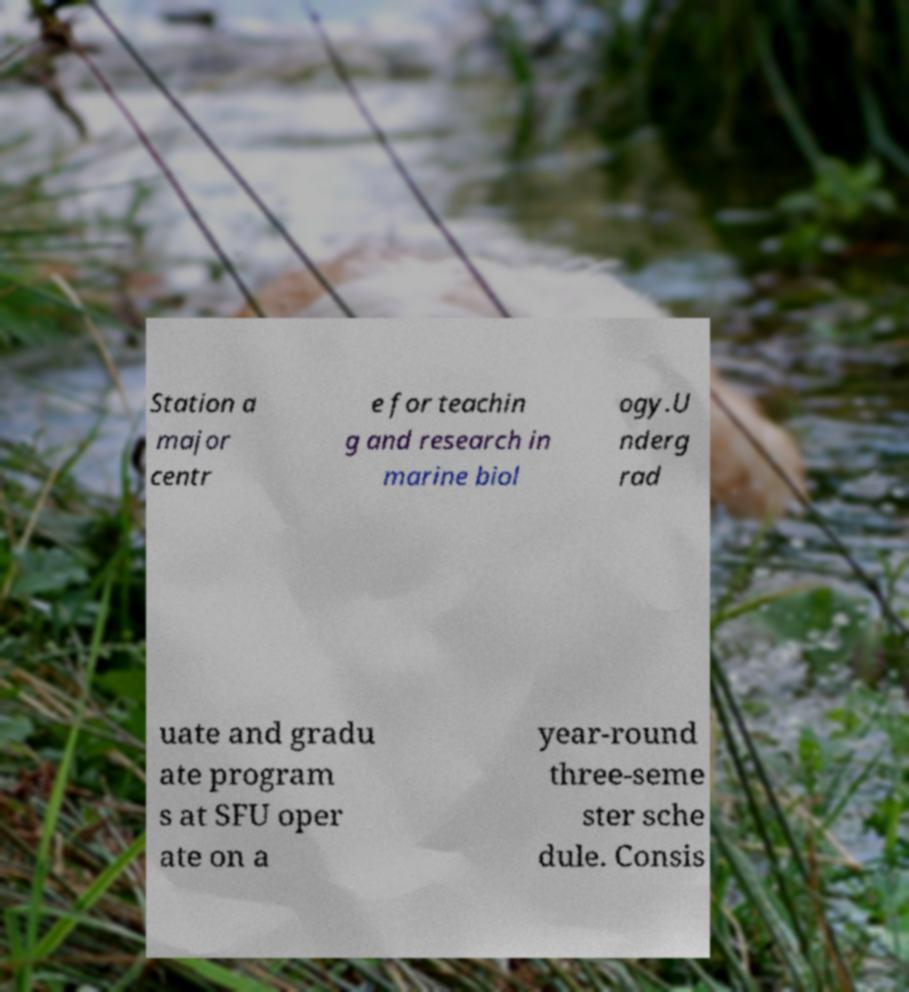Can you read and provide the text displayed in the image?This photo seems to have some interesting text. Can you extract and type it out for me? Station a major centr e for teachin g and research in marine biol ogy.U nderg rad uate and gradu ate program s at SFU oper ate on a year-round three-seme ster sche dule. Consis 